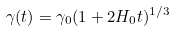Convert formula to latex. <formula><loc_0><loc_0><loc_500><loc_500>\gamma ( t ) = \gamma _ { 0 } ( 1 + 2 H _ { 0 } t ) ^ { 1 / 3 }</formula> 